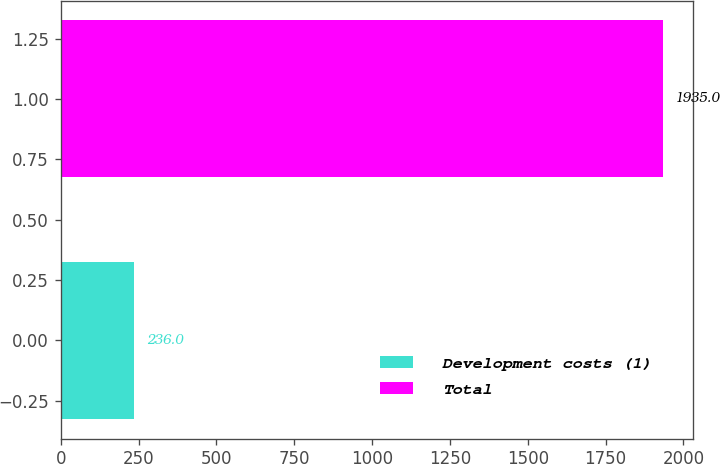Convert chart to OTSL. <chart><loc_0><loc_0><loc_500><loc_500><bar_chart><fcel>Development costs (1)<fcel>Total<nl><fcel>236<fcel>1935<nl></chart> 